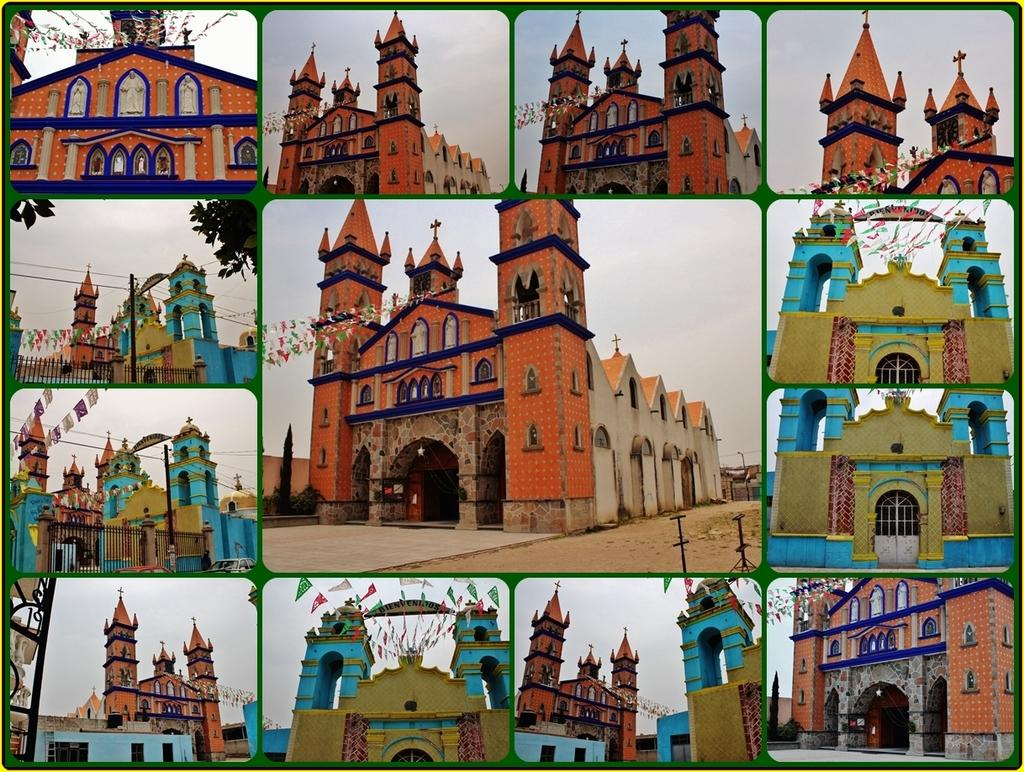What type of artwork is depicted in the image? The image is a collage. What is the common theme among the images in the collage? Each image in the collage contains a church. What type of hair can be seen on the ornament in the image? There is no ornament or hair present in the image; the collage consists of images of churches. 